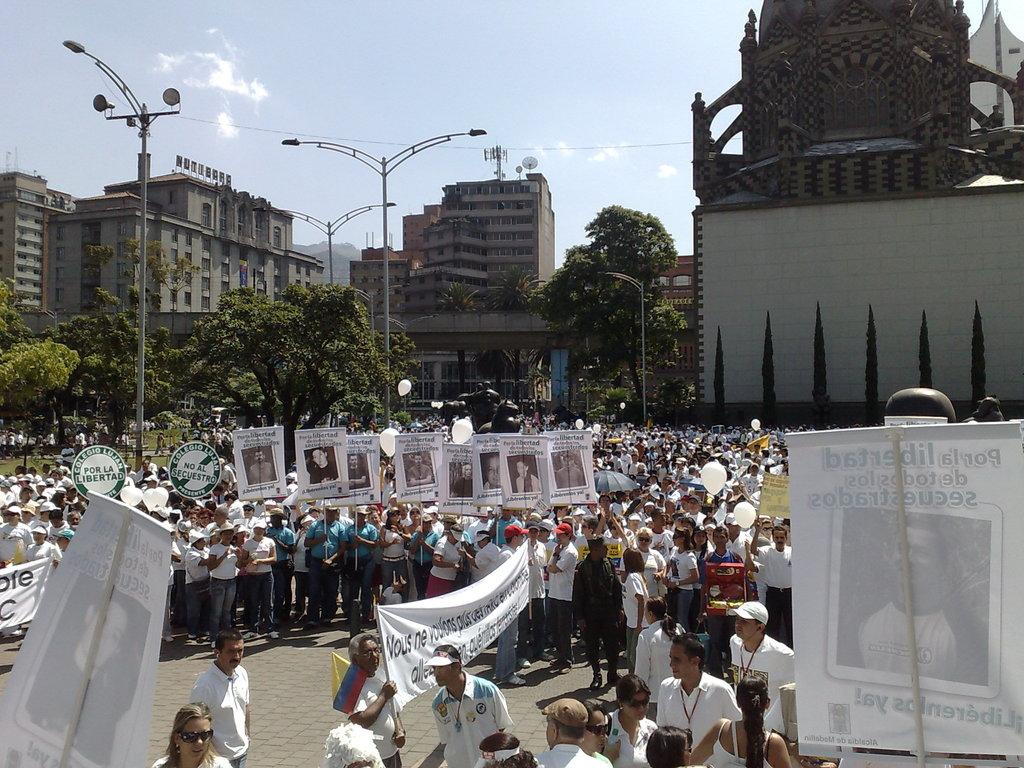Who or what can be seen in the image? There are people in the image. What decorative elements are present in the image? There are banners and balloons in the image. What structures can be seen in the image? There are poles, trees, and buildings in the image. What is visible in the background of the image? The sky is visible in the background of the image, with clouds present. What type of cloth is being used to cover the passenger in the image? There is no passenger present in the image, and therefore no cloth covering anyone. 